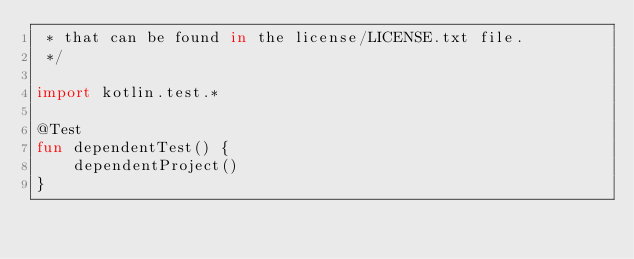Convert code to text. <code><loc_0><loc_0><loc_500><loc_500><_Kotlin_> * that can be found in the license/LICENSE.txt file.
 */

import kotlin.test.*

@Test
fun dependentTest() {
    dependentProject()
}
</code> 